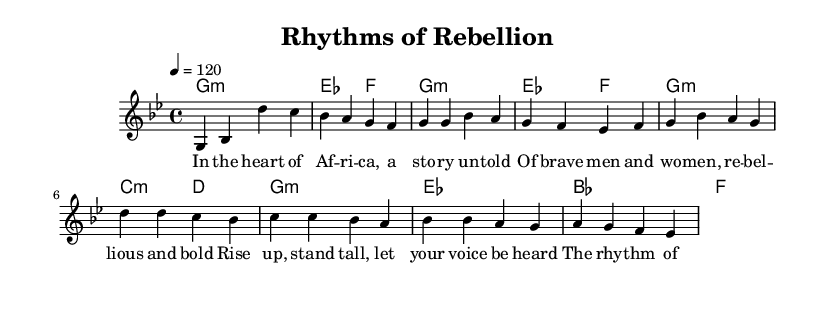What is the key signature of this music? The key signature is G minor, which has two flats (B flat and E flat). This can be derived from the header information and the initial indication of the key in the global section.
Answer: G minor What is the time signature of the piece? The time signature shown in the global section is 4/4, which means there are 4 beats per measure, and each quarter note gets one beat. This is noted directly in the global section of the code.
Answer: 4/4 What is the tempo marking of the music? The tempo marking in the global section indicates a speed of 120 beats per minute, which is a common tempo for pop music. This is specified in the global section.
Answer: 120 What is the chord for the chorus's first measure? The first measure of the chorus is marked with a chord G minor, which can be determined from the harmonies section in the score.
Answer: G minor What thematic elements are conveyed in the lyrics of the song? The lyrics reflect themes of rebellion and freedom, as highlighted in phrases that mention standing tall and the rhythm of freedom. This thematic reflection is derived from the words used in both the verse and chorus.
Answer: Rebellion and freedom What style of music does this piece represent? This piece represents pop music fusions, blending traditional African rhythms indicated by the title "Rhythms of Rebellion" with modern musical elements such as a steady tempo and chord structure. This can be deduced from the title and the arrangement of the music itself.
Answer: Pop fusion 